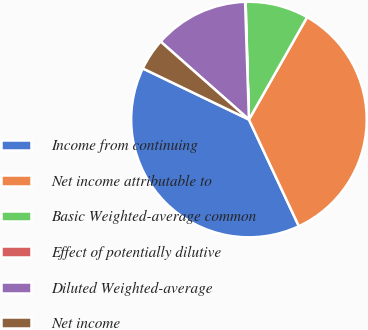Convert chart to OTSL. <chart><loc_0><loc_0><loc_500><loc_500><pie_chart><fcel>Income from continuing<fcel>Net income attributable to<fcel>Basic Weighted-average common<fcel>Effect of potentially dilutive<fcel>Diluted Weighted-average<fcel>Net income<nl><fcel>39.11%<fcel>34.81%<fcel>8.67%<fcel>0.07%<fcel>12.97%<fcel>4.37%<nl></chart> 